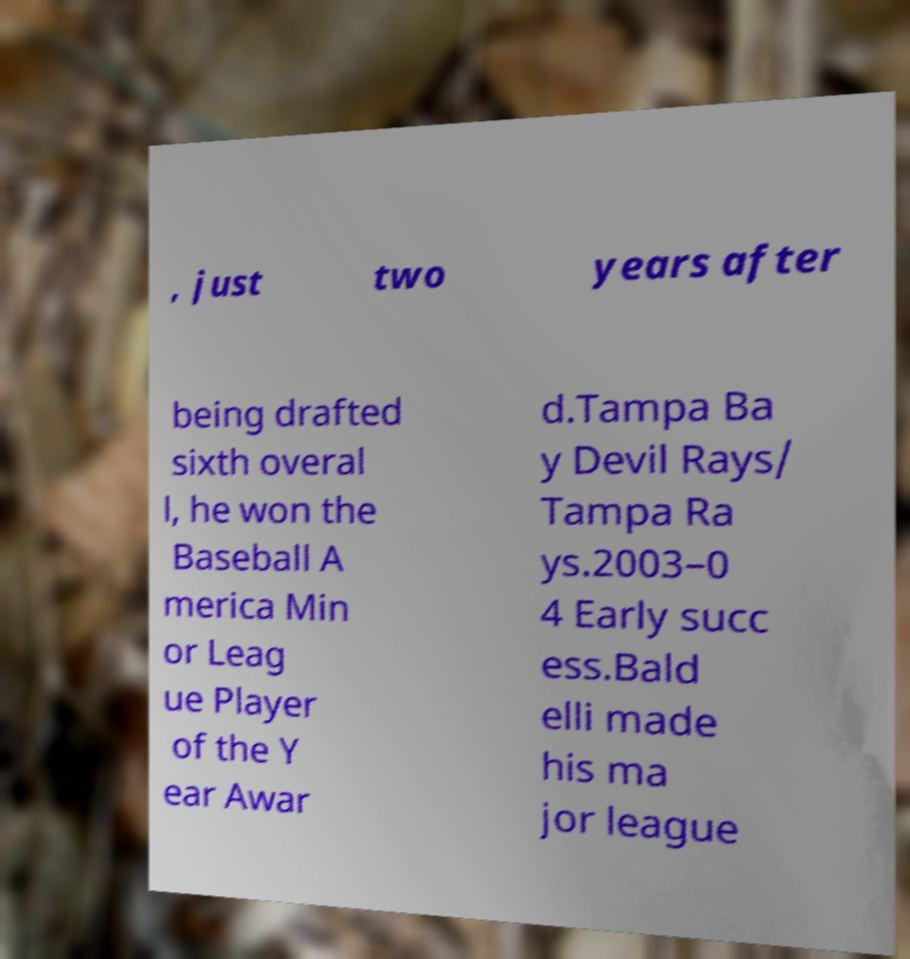I need the written content from this picture converted into text. Can you do that? , just two years after being drafted sixth overal l, he won the Baseball A merica Min or Leag ue Player of the Y ear Awar d.Tampa Ba y Devil Rays/ Tampa Ra ys.2003–0 4 Early succ ess.Bald elli made his ma jor league 